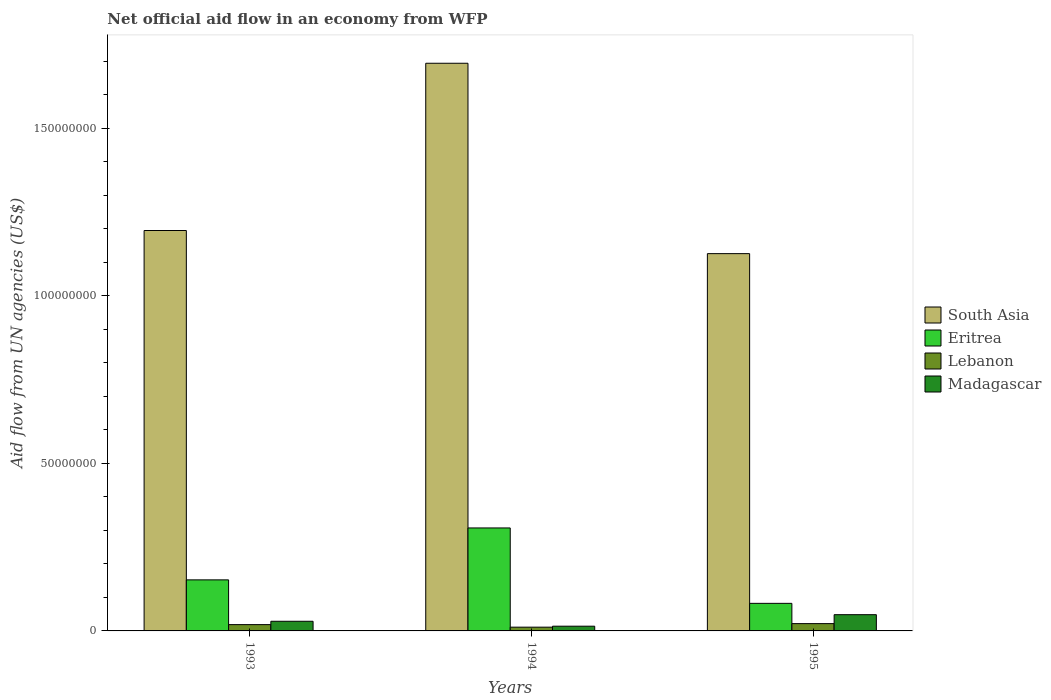How many groups of bars are there?
Your answer should be very brief. 3. Are the number of bars per tick equal to the number of legend labels?
Offer a very short reply. Yes. Are the number of bars on each tick of the X-axis equal?
Make the answer very short. Yes. How many bars are there on the 3rd tick from the left?
Keep it short and to the point. 4. In how many cases, is the number of bars for a given year not equal to the number of legend labels?
Your answer should be very brief. 0. What is the net official aid flow in South Asia in 1994?
Offer a very short reply. 1.69e+08. Across all years, what is the maximum net official aid flow in South Asia?
Make the answer very short. 1.69e+08. Across all years, what is the minimum net official aid flow in Eritrea?
Keep it short and to the point. 8.23e+06. What is the total net official aid flow in Eritrea in the graph?
Your answer should be compact. 5.42e+07. What is the difference between the net official aid flow in South Asia in 1993 and that in 1995?
Provide a short and direct response. 6.90e+06. What is the difference between the net official aid flow in Lebanon in 1993 and the net official aid flow in South Asia in 1994?
Your answer should be compact. -1.68e+08. What is the average net official aid flow in Eritrea per year?
Your answer should be compact. 1.81e+07. In the year 1995, what is the difference between the net official aid flow in Madagascar and net official aid flow in Eritrea?
Your answer should be compact. -3.38e+06. What is the ratio of the net official aid flow in South Asia in 1993 to that in 1994?
Offer a very short reply. 0.71. Is the net official aid flow in South Asia in 1994 less than that in 1995?
Ensure brevity in your answer.  No. Is the difference between the net official aid flow in Madagascar in 1993 and 1995 greater than the difference between the net official aid flow in Eritrea in 1993 and 1995?
Your response must be concise. No. What is the difference between the highest and the second highest net official aid flow in Madagascar?
Offer a terse response. 1.97e+06. What is the difference between the highest and the lowest net official aid flow in Lebanon?
Provide a succinct answer. 1.06e+06. Is it the case that in every year, the sum of the net official aid flow in Eritrea and net official aid flow in Madagascar is greater than the sum of net official aid flow in South Asia and net official aid flow in Lebanon?
Offer a very short reply. No. What does the 3rd bar from the left in 1993 represents?
Provide a succinct answer. Lebanon. What does the 3rd bar from the right in 1994 represents?
Offer a very short reply. Eritrea. Is it the case that in every year, the sum of the net official aid flow in Madagascar and net official aid flow in Lebanon is greater than the net official aid flow in Eritrea?
Your answer should be very brief. No. Does the graph contain grids?
Your answer should be compact. No. What is the title of the graph?
Provide a succinct answer. Net official aid flow in an economy from WFP. Does "Guinea-Bissau" appear as one of the legend labels in the graph?
Your answer should be very brief. No. What is the label or title of the Y-axis?
Make the answer very short. Aid flow from UN agencies (US$). What is the Aid flow from UN agencies (US$) in South Asia in 1993?
Ensure brevity in your answer.  1.20e+08. What is the Aid flow from UN agencies (US$) in Eritrea in 1993?
Keep it short and to the point. 1.52e+07. What is the Aid flow from UN agencies (US$) in Lebanon in 1993?
Give a very brief answer. 1.88e+06. What is the Aid flow from UN agencies (US$) in Madagascar in 1993?
Keep it short and to the point. 2.88e+06. What is the Aid flow from UN agencies (US$) of South Asia in 1994?
Offer a terse response. 1.69e+08. What is the Aid flow from UN agencies (US$) in Eritrea in 1994?
Make the answer very short. 3.07e+07. What is the Aid flow from UN agencies (US$) in Lebanon in 1994?
Your response must be concise. 1.12e+06. What is the Aid flow from UN agencies (US$) of Madagascar in 1994?
Provide a short and direct response. 1.41e+06. What is the Aid flow from UN agencies (US$) in South Asia in 1995?
Provide a short and direct response. 1.13e+08. What is the Aid flow from UN agencies (US$) in Eritrea in 1995?
Your answer should be compact. 8.23e+06. What is the Aid flow from UN agencies (US$) of Lebanon in 1995?
Provide a succinct answer. 2.18e+06. What is the Aid flow from UN agencies (US$) in Madagascar in 1995?
Offer a terse response. 4.85e+06. Across all years, what is the maximum Aid flow from UN agencies (US$) in South Asia?
Give a very brief answer. 1.69e+08. Across all years, what is the maximum Aid flow from UN agencies (US$) in Eritrea?
Offer a very short reply. 3.07e+07. Across all years, what is the maximum Aid flow from UN agencies (US$) of Lebanon?
Offer a very short reply. 2.18e+06. Across all years, what is the maximum Aid flow from UN agencies (US$) in Madagascar?
Your answer should be compact. 4.85e+06. Across all years, what is the minimum Aid flow from UN agencies (US$) of South Asia?
Provide a short and direct response. 1.13e+08. Across all years, what is the minimum Aid flow from UN agencies (US$) in Eritrea?
Make the answer very short. 8.23e+06. Across all years, what is the minimum Aid flow from UN agencies (US$) of Lebanon?
Your response must be concise. 1.12e+06. Across all years, what is the minimum Aid flow from UN agencies (US$) of Madagascar?
Keep it short and to the point. 1.41e+06. What is the total Aid flow from UN agencies (US$) of South Asia in the graph?
Your answer should be compact. 4.02e+08. What is the total Aid flow from UN agencies (US$) in Eritrea in the graph?
Ensure brevity in your answer.  5.42e+07. What is the total Aid flow from UN agencies (US$) of Lebanon in the graph?
Offer a terse response. 5.18e+06. What is the total Aid flow from UN agencies (US$) in Madagascar in the graph?
Provide a short and direct response. 9.14e+06. What is the difference between the Aid flow from UN agencies (US$) in South Asia in 1993 and that in 1994?
Keep it short and to the point. -4.99e+07. What is the difference between the Aid flow from UN agencies (US$) of Eritrea in 1993 and that in 1994?
Your answer should be compact. -1.55e+07. What is the difference between the Aid flow from UN agencies (US$) of Lebanon in 1993 and that in 1994?
Your response must be concise. 7.60e+05. What is the difference between the Aid flow from UN agencies (US$) of Madagascar in 1993 and that in 1994?
Offer a very short reply. 1.47e+06. What is the difference between the Aid flow from UN agencies (US$) in South Asia in 1993 and that in 1995?
Give a very brief answer. 6.90e+06. What is the difference between the Aid flow from UN agencies (US$) of Eritrea in 1993 and that in 1995?
Offer a terse response. 7.01e+06. What is the difference between the Aid flow from UN agencies (US$) in Madagascar in 1993 and that in 1995?
Offer a terse response. -1.97e+06. What is the difference between the Aid flow from UN agencies (US$) of South Asia in 1994 and that in 1995?
Your answer should be very brief. 5.68e+07. What is the difference between the Aid flow from UN agencies (US$) in Eritrea in 1994 and that in 1995?
Make the answer very short. 2.25e+07. What is the difference between the Aid flow from UN agencies (US$) of Lebanon in 1994 and that in 1995?
Offer a terse response. -1.06e+06. What is the difference between the Aid flow from UN agencies (US$) in Madagascar in 1994 and that in 1995?
Make the answer very short. -3.44e+06. What is the difference between the Aid flow from UN agencies (US$) in South Asia in 1993 and the Aid flow from UN agencies (US$) in Eritrea in 1994?
Offer a terse response. 8.88e+07. What is the difference between the Aid flow from UN agencies (US$) in South Asia in 1993 and the Aid flow from UN agencies (US$) in Lebanon in 1994?
Keep it short and to the point. 1.18e+08. What is the difference between the Aid flow from UN agencies (US$) of South Asia in 1993 and the Aid flow from UN agencies (US$) of Madagascar in 1994?
Offer a very short reply. 1.18e+08. What is the difference between the Aid flow from UN agencies (US$) in Eritrea in 1993 and the Aid flow from UN agencies (US$) in Lebanon in 1994?
Make the answer very short. 1.41e+07. What is the difference between the Aid flow from UN agencies (US$) in Eritrea in 1993 and the Aid flow from UN agencies (US$) in Madagascar in 1994?
Provide a succinct answer. 1.38e+07. What is the difference between the Aid flow from UN agencies (US$) in Lebanon in 1993 and the Aid flow from UN agencies (US$) in Madagascar in 1994?
Provide a succinct answer. 4.70e+05. What is the difference between the Aid flow from UN agencies (US$) of South Asia in 1993 and the Aid flow from UN agencies (US$) of Eritrea in 1995?
Ensure brevity in your answer.  1.11e+08. What is the difference between the Aid flow from UN agencies (US$) in South Asia in 1993 and the Aid flow from UN agencies (US$) in Lebanon in 1995?
Offer a very short reply. 1.17e+08. What is the difference between the Aid flow from UN agencies (US$) in South Asia in 1993 and the Aid flow from UN agencies (US$) in Madagascar in 1995?
Ensure brevity in your answer.  1.15e+08. What is the difference between the Aid flow from UN agencies (US$) in Eritrea in 1993 and the Aid flow from UN agencies (US$) in Lebanon in 1995?
Keep it short and to the point. 1.31e+07. What is the difference between the Aid flow from UN agencies (US$) in Eritrea in 1993 and the Aid flow from UN agencies (US$) in Madagascar in 1995?
Make the answer very short. 1.04e+07. What is the difference between the Aid flow from UN agencies (US$) of Lebanon in 1993 and the Aid flow from UN agencies (US$) of Madagascar in 1995?
Offer a very short reply. -2.97e+06. What is the difference between the Aid flow from UN agencies (US$) of South Asia in 1994 and the Aid flow from UN agencies (US$) of Eritrea in 1995?
Keep it short and to the point. 1.61e+08. What is the difference between the Aid flow from UN agencies (US$) of South Asia in 1994 and the Aid flow from UN agencies (US$) of Lebanon in 1995?
Your response must be concise. 1.67e+08. What is the difference between the Aid flow from UN agencies (US$) of South Asia in 1994 and the Aid flow from UN agencies (US$) of Madagascar in 1995?
Offer a very short reply. 1.65e+08. What is the difference between the Aid flow from UN agencies (US$) of Eritrea in 1994 and the Aid flow from UN agencies (US$) of Lebanon in 1995?
Provide a succinct answer. 2.86e+07. What is the difference between the Aid flow from UN agencies (US$) of Eritrea in 1994 and the Aid flow from UN agencies (US$) of Madagascar in 1995?
Provide a short and direct response. 2.59e+07. What is the difference between the Aid flow from UN agencies (US$) in Lebanon in 1994 and the Aid flow from UN agencies (US$) in Madagascar in 1995?
Offer a very short reply. -3.73e+06. What is the average Aid flow from UN agencies (US$) in South Asia per year?
Your answer should be compact. 1.34e+08. What is the average Aid flow from UN agencies (US$) of Eritrea per year?
Keep it short and to the point. 1.81e+07. What is the average Aid flow from UN agencies (US$) of Lebanon per year?
Make the answer very short. 1.73e+06. What is the average Aid flow from UN agencies (US$) of Madagascar per year?
Ensure brevity in your answer.  3.05e+06. In the year 1993, what is the difference between the Aid flow from UN agencies (US$) in South Asia and Aid flow from UN agencies (US$) in Eritrea?
Your response must be concise. 1.04e+08. In the year 1993, what is the difference between the Aid flow from UN agencies (US$) of South Asia and Aid flow from UN agencies (US$) of Lebanon?
Provide a succinct answer. 1.18e+08. In the year 1993, what is the difference between the Aid flow from UN agencies (US$) in South Asia and Aid flow from UN agencies (US$) in Madagascar?
Keep it short and to the point. 1.17e+08. In the year 1993, what is the difference between the Aid flow from UN agencies (US$) of Eritrea and Aid flow from UN agencies (US$) of Lebanon?
Offer a very short reply. 1.34e+07. In the year 1993, what is the difference between the Aid flow from UN agencies (US$) of Eritrea and Aid flow from UN agencies (US$) of Madagascar?
Offer a terse response. 1.24e+07. In the year 1994, what is the difference between the Aid flow from UN agencies (US$) of South Asia and Aid flow from UN agencies (US$) of Eritrea?
Your answer should be compact. 1.39e+08. In the year 1994, what is the difference between the Aid flow from UN agencies (US$) of South Asia and Aid flow from UN agencies (US$) of Lebanon?
Your answer should be very brief. 1.68e+08. In the year 1994, what is the difference between the Aid flow from UN agencies (US$) in South Asia and Aid flow from UN agencies (US$) in Madagascar?
Your answer should be compact. 1.68e+08. In the year 1994, what is the difference between the Aid flow from UN agencies (US$) in Eritrea and Aid flow from UN agencies (US$) in Lebanon?
Your answer should be very brief. 2.96e+07. In the year 1994, what is the difference between the Aid flow from UN agencies (US$) in Eritrea and Aid flow from UN agencies (US$) in Madagascar?
Your response must be concise. 2.93e+07. In the year 1995, what is the difference between the Aid flow from UN agencies (US$) in South Asia and Aid flow from UN agencies (US$) in Eritrea?
Offer a very short reply. 1.04e+08. In the year 1995, what is the difference between the Aid flow from UN agencies (US$) of South Asia and Aid flow from UN agencies (US$) of Lebanon?
Your answer should be compact. 1.10e+08. In the year 1995, what is the difference between the Aid flow from UN agencies (US$) of South Asia and Aid flow from UN agencies (US$) of Madagascar?
Offer a terse response. 1.08e+08. In the year 1995, what is the difference between the Aid flow from UN agencies (US$) in Eritrea and Aid flow from UN agencies (US$) in Lebanon?
Give a very brief answer. 6.05e+06. In the year 1995, what is the difference between the Aid flow from UN agencies (US$) in Eritrea and Aid flow from UN agencies (US$) in Madagascar?
Provide a succinct answer. 3.38e+06. In the year 1995, what is the difference between the Aid flow from UN agencies (US$) in Lebanon and Aid flow from UN agencies (US$) in Madagascar?
Your response must be concise. -2.67e+06. What is the ratio of the Aid flow from UN agencies (US$) in South Asia in 1993 to that in 1994?
Keep it short and to the point. 0.71. What is the ratio of the Aid flow from UN agencies (US$) of Eritrea in 1993 to that in 1994?
Ensure brevity in your answer.  0.5. What is the ratio of the Aid flow from UN agencies (US$) in Lebanon in 1993 to that in 1994?
Provide a short and direct response. 1.68. What is the ratio of the Aid flow from UN agencies (US$) in Madagascar in 1993 to that in 1994?
Ensure brevity in your answer.  2.04. What is the ratio of the Aid flow from UN agencies (US$) in South Asia in 1993 to that in 1995?
Provide a short and direct response. 1.06. What is the ratio of the Aid flow from UN agencies (US$) of Eritrea in 1993 to that in 1995?
Make the answer very short. 1.85. What is the ratio of the Aid flow from UN agencies (US$) in Lebanon in 1993 to that in 1995?
Offer a terse response. 0.86. What is the ratio of the Aid flow from UN agencies (US$) of Madagascar in 1993 to that in 1995?
Keep it short and to the point. 0.59. What is the ratio of the Aid flow from UN agencies (US$) of South Asia in 1994 to that in 1995?
Ensure brevity in your answer.  1.5. What is the ratio of the Aid flow from UN agencies (US$) of Eritrea in 1994 to that in 1995?
Offer a very short reply. 3.74. What is the ratio of the Aid flow from UN agencies (US$) in Lebanon in 1994 to that in 1995?
Provide a succinct answer. 0.51. What is the ratio of the Aid flow from UN agencies (US$) of Madagascar in 1994 to that in 1995?
Offer a terse response. 0.29. What is the difference between the highest and the second highest Aid flow from UN agencies (US$) of South Asia?
Offer a very short reply. 4.99e+07. What is the difference between the highest and the second highest Aid flow from UN agencies (US$) of Eritrea?
Ensure brevity in your answer.  1.55e+07. What is the difference between the highest and the second highest Aid flow from UN agencies (US$) in Lebanon?
Your answer should be very brief. 3.00e+05. What is the difference between the highest and the second highest Aid flow from UN agencies (US$) of Madagascar?
Keep it short and to the point. 1.97e+06. What is the difference between the highest and the lowest Aid flow from UN agencies (US$) of South Asia?
Keep it short and to the point. 5.68e+07. What is the difference between the highest and the lowest Aid flow from UN agencies (US$) in Eritrea?
Provide a short and direct response. 2.25e+07. What is the difference between the highest and the lowest Aid flow from UN agencies (US$) of Lebanon?
Your answer should be compact. 1.06e+06. What is the difference between the highest and the lowest Aid flow from UN agencies (US$) in Madagascar?
Make the answer very short. 3.44e+06. 